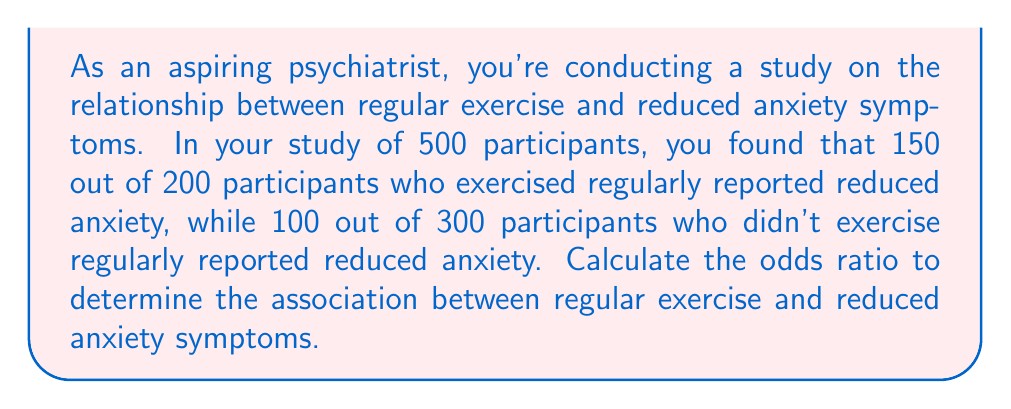Solve this math problem. To calculate the odds ratio, we need to follow these steps:

1. Create a 2x2 contingency table:

   | Reduced Anxiety | No Reduced Anxiety | Total |
   |-----------------|---------------------|-------|
   | Exercise        | 150                 | 50    | 200 |
   | No Exercise     | 100                 | 200   | 300 |

2. Calculate the odds for each group:

   Odds for exercise group: 
   $$\text{Odds}_1 = \frac{150}{50} = 3$$

   Odds for no exercise group:
   $$\text{Odds}_2 = \frac{100}{200} = 0.5$$

3. Calculate the odds ratio:

   $$\text{Odds Ratio} = \frac{\text{Odds}_1}{\text{Odds}_2} = \frac{3}{0.5} = 6$$

The odds ratio formula can also be expressed as:

$$\text{Odds Ratio} = \frac{a \times d}{b \times c}$$

Where:
a = number of exposed individuals with the outcome
b = number of exposed individuals without the outcome
c = number of unexposed individuals with the outcome
d = number of unexposed individuals without the outcome

Plugging in our values:

$$\text{Odds Ratio} = \frac{150 \times 200}{50 \times 100} = \frac{30000}{5000} = 6$$

Interpretation: The odds of reduced anxiety symptoms for those who exercise regularly are 6 times higher than for those who don't exercise regularly.
Answer: The odds ratio is 6, indicating that regular exercise is associated with a higher likelihood of reduced anxiety symptoms. 